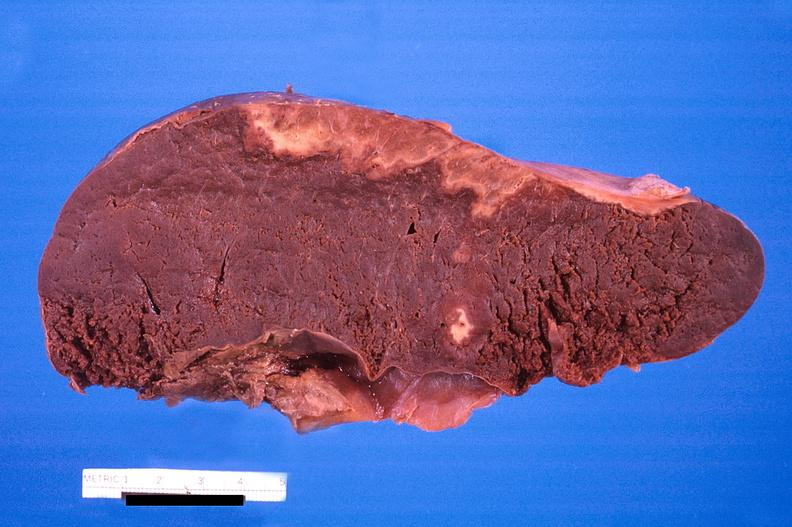how is spleen , infarcts , disseminated coagulation?
Answer the question using a single word or phrase. Intravascular 